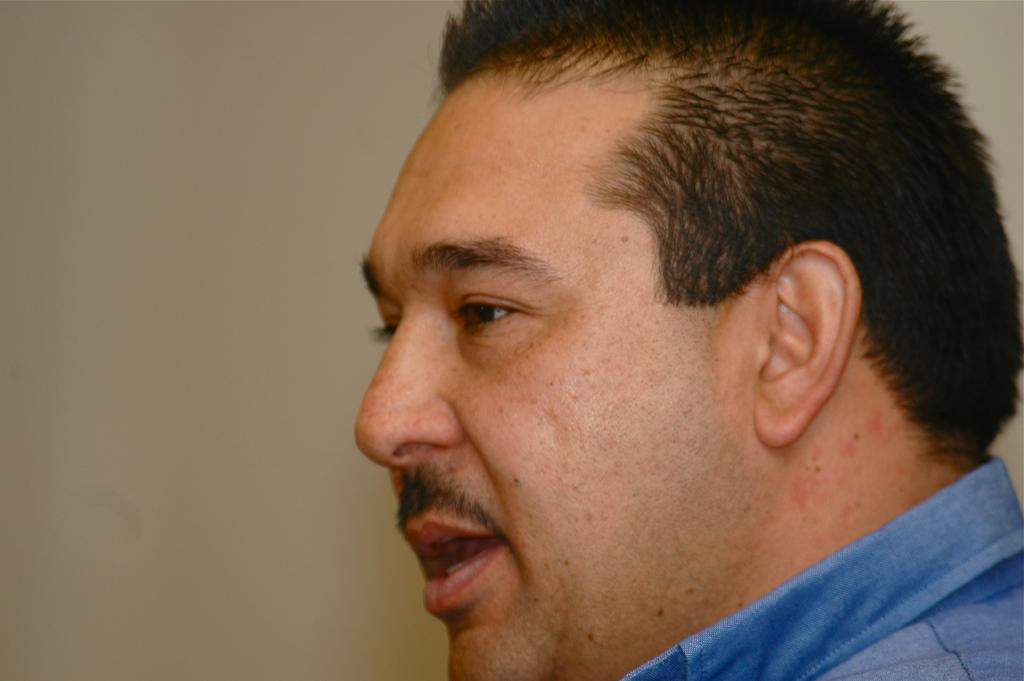What is the main subject of the picture? The main subject of the picture is a man. In which direction is the man facing? The man is facing towards the left. What is the man wearing in the picture? The man is wearing a blue shirt. What type of watch is the man wearing in the image? There is no watch visible in the image. 